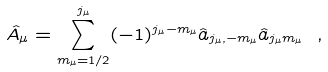Convert formula to latex. <formula><loc_0><loc_0><loc_500><loc_500>\hat { A } _ { \mu } = \sum _ { m _ { \mu } = 1 / 2 } ^ { j _ { \mu } } ( - 1 ) ^ { j _ { \mu } - m _ { \mu } } \hat { a } _ { j _ { \mu } , - m _ { \mu } } \hat { a } _ { j _ { \mu } m _ { \mu } } \ ,</formula> 